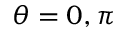<formula> <loc_0><loc_0><loc_500><loc_500>\theta = 0 , \pi</formula> 